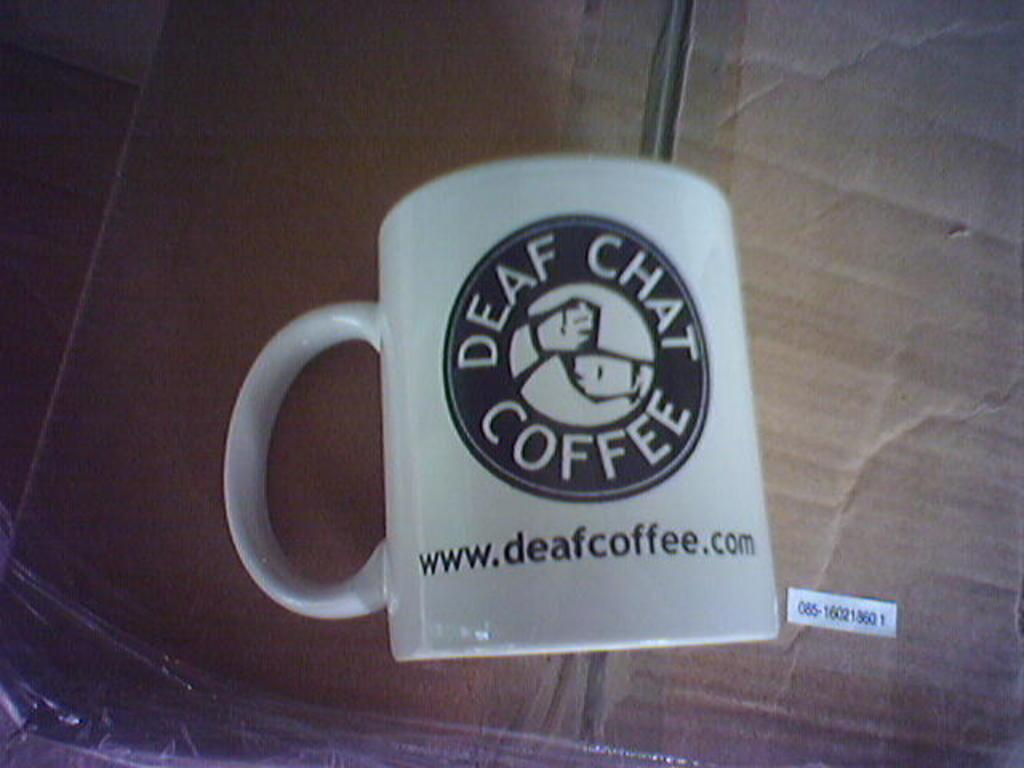What type of container is visible in the image? There is a white coffee mug in the image. What is written or printed on the mug? There is text on the mug. Where is the mug placed in the image? The mug is placed on a brown box. What type of stamp can be seen on the mug in the image? There is no stamp visible on the mug in the image. 